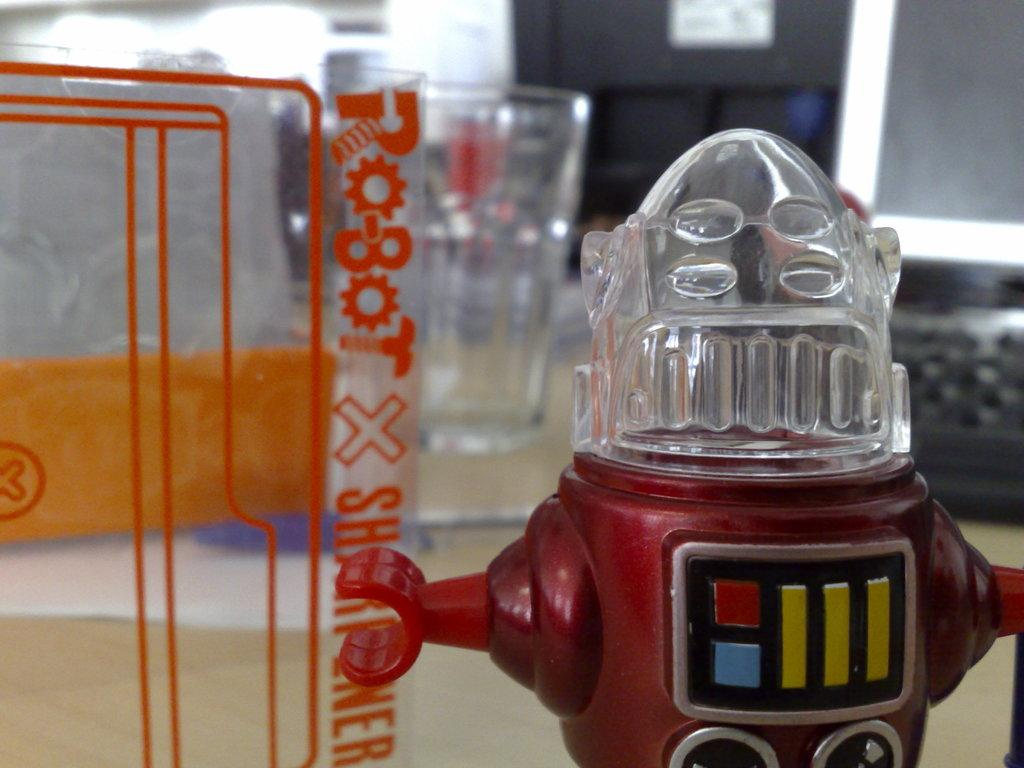Provide a one-sentence caption for the provided image. A robot with a see through glass head standing on a floor pointing to robot x. 